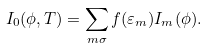<formula> <loc_0><loc_0><loc_500><loc_500>I _ { 0 } ( \phi , T ) = \sum _ { m \sigma } f ( \varepsilon _ { m } ) I _ { m } ( \phi ) .</formula> 